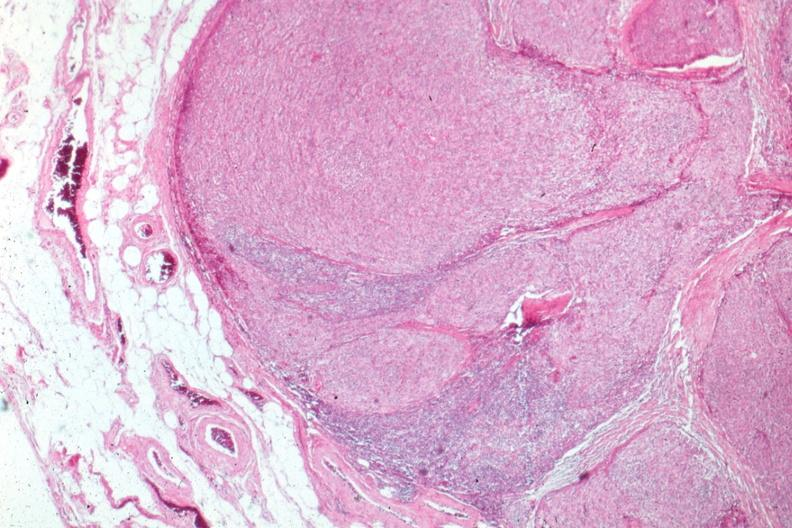does leiomyosarcoma show surgical specimen?
Answer the question using a single word or phrase. No 